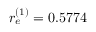<formula> <loc_0><loc_0><loc_500><loc_500>r _ { e } ^ { ( 1 ) } = 0 . 5 7 7 4</formula> 